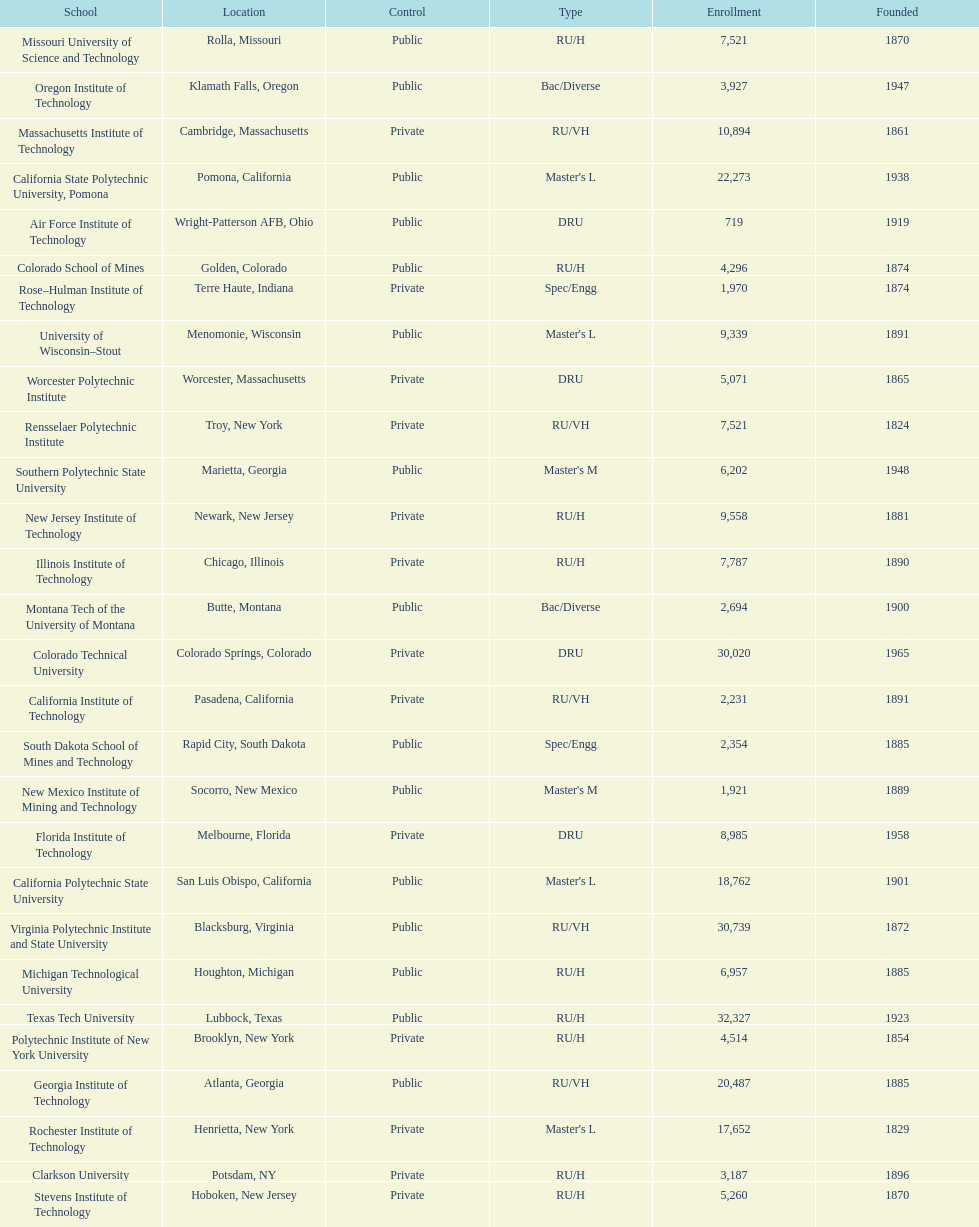How many of the universities were located in california? 3. 